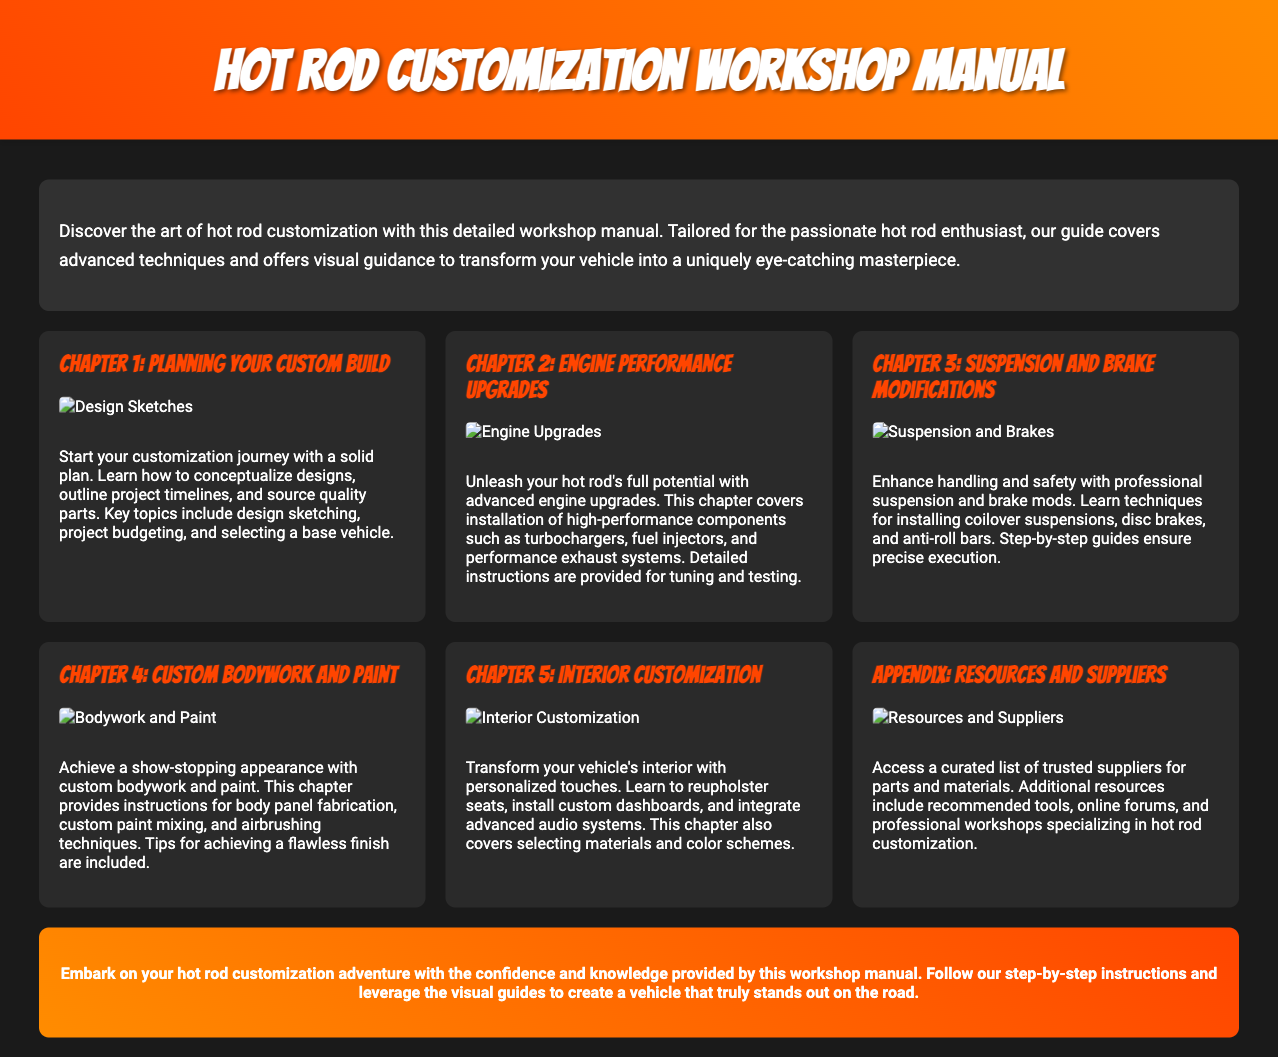What is the title of the manual? The title is prominently displayed at the top of the document, indicating the subject matter of the manual.
Answer: Hot Rod Customization Workshop Manual How many chapters are included in the manual? The document lists a total of six sections, including the main chapters and an appendix.
Answer: 6 What does Chapter 2 focus on? Each chapter title represents its content, with Chapter 2 specifically addressing enhancements for the engine.
Answer: Engine Performance Upgrades Which chapter covers custom bodywork and paint? The title of Chapter 4 directly indicates its focus on bodywork and painting techniques.
Answer: Chapter 4: Custom Bodywork and Paint What visual elements are included in the chapters? The document references images accompanying each chapter, which serve as visual guides for the techniques described.
Answer: Images What is the purpose of the appendix? The appendix provides additional information that supports the main content, focusing on resources for customization.
Answer: Resources and Suppliers Which chapter would you refer to for transforming your vehicle's interior? The document provides clear chapter titles, with a specific chapter dedicated to interior customization techniques.
Answer: Chapter 5: Interior Customization What is emphasized in the conclusion of the manual? The conclusion summarizes the manual's goal of equipping enthusiasts with the knowledge to customize their vehicles effectively.
Answer: Confidence and knowledge 